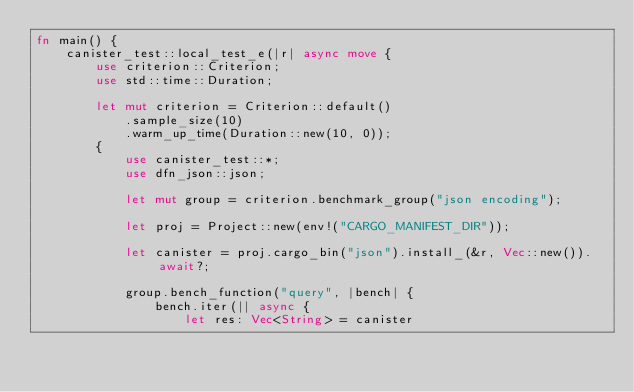Convert code to text. <code><loc_0><loc_0><loc_500><loc_500><_Rust_>fn main() {
    canister_test::local_test_e(|r| async move {
        use criterion::Criterion;
        use std::time::Duration;

        let mut criterion = Criterion::default()
            .sample_size(10)
            .warm_up_time(Duration::new(10, 0));
        {
            use canister_test::*;
            use dfn_json::json;

            let mut group = criterion.benchmark_group("json encoding");

            let proj = Project::new(env!("CARGO_MANIFEST_DIR"));

            let canister = proj.cargo_bin("json").install_(&r, Vec::new()).await?;

            group.bench_function("query", |bench| {
                bench.iter(|| async {
                    let res: Vec<String> = canister</code> 